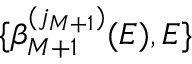Convert formula to latex. <formula><loc_0><loc_0><loc_500><loc_500>\{ \beta _ { M + 1 } ^ { ( j _ { M + 1 } ) } ( E ) , E \}</formula> 